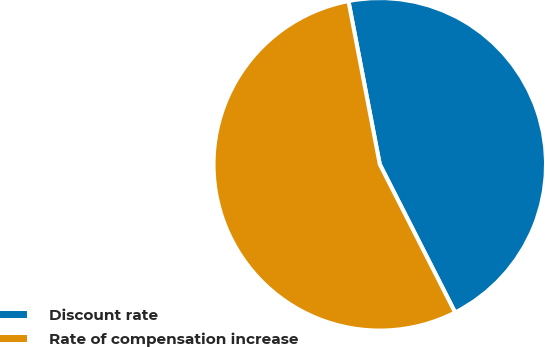Convert chart. <chart><loc_0><loc_0><loc_500><loc_500><pie_chart><fcel>Discount rate<fcel>Rate of compensation increase<nl><fcel>45.53%<fcel>54.47%<nl></chart> 